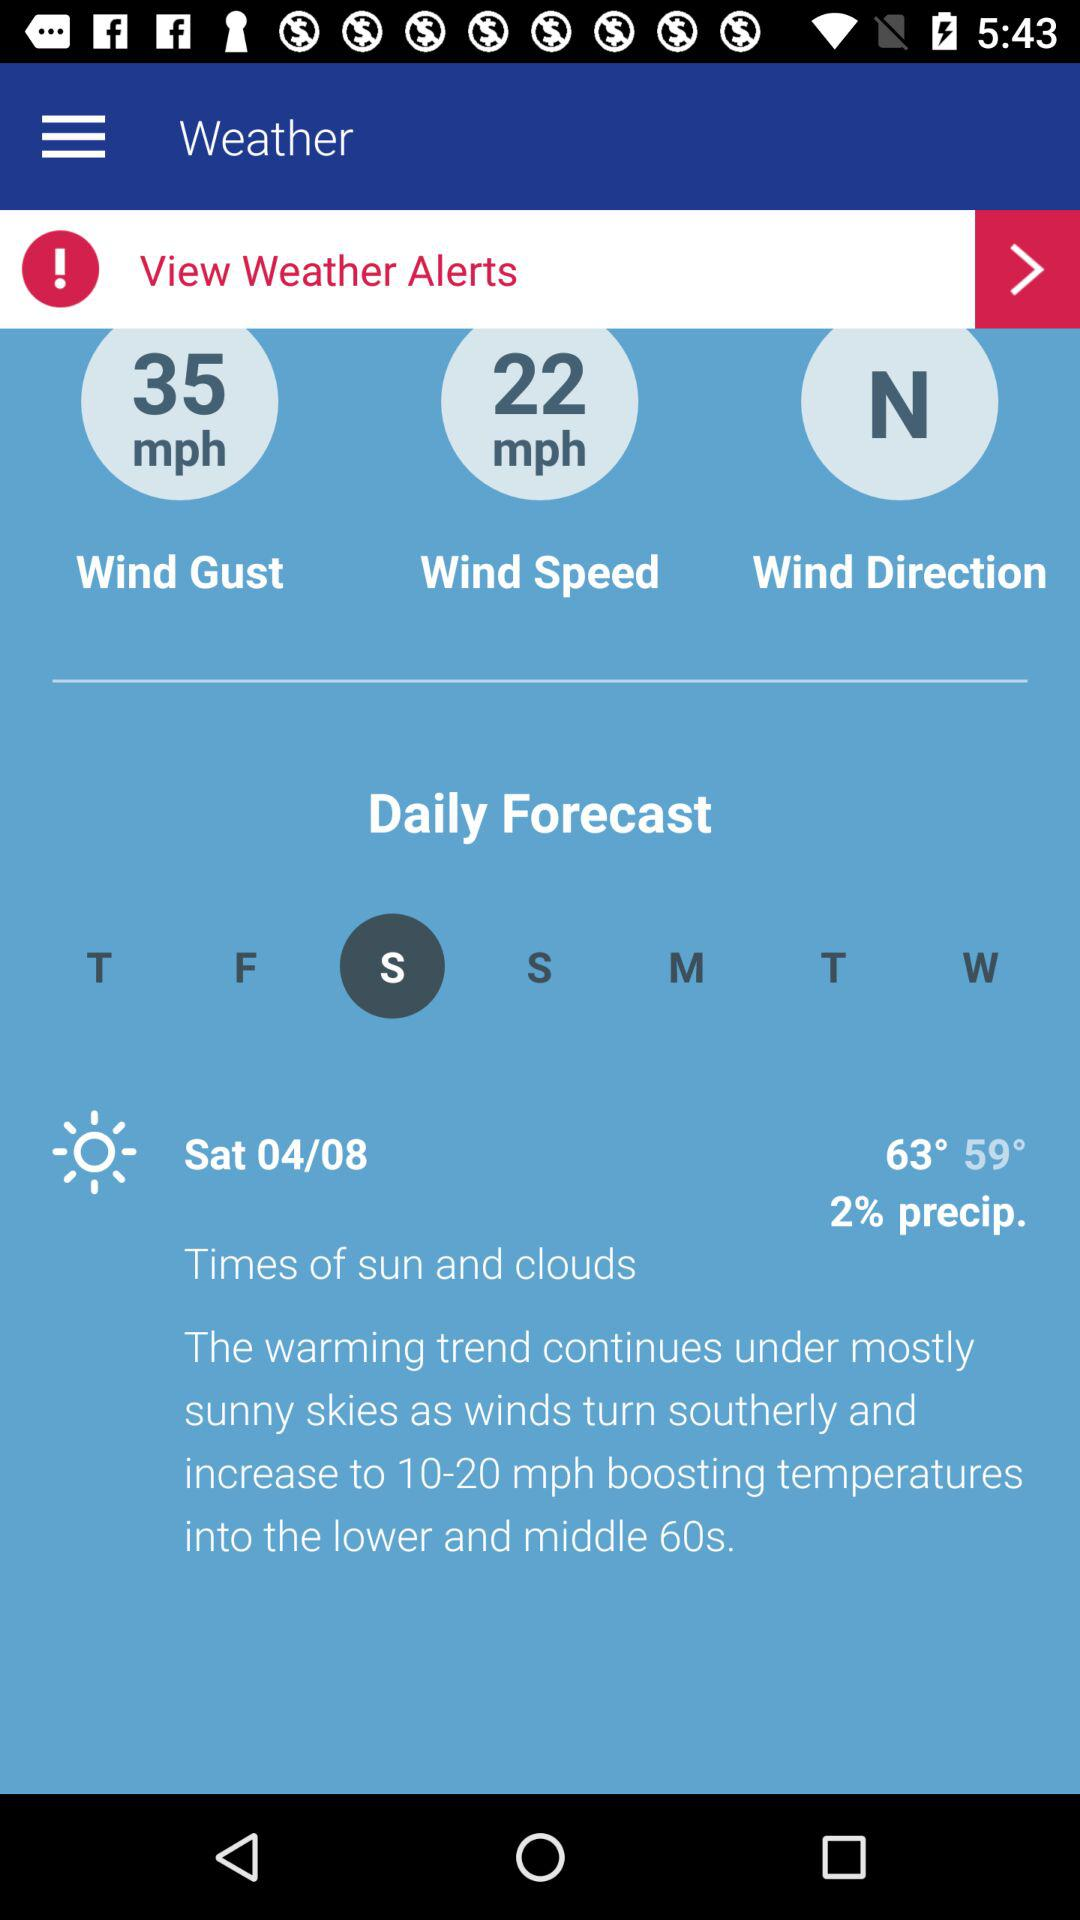What is the wind speed? The wind speed is 22 miles per hour. 